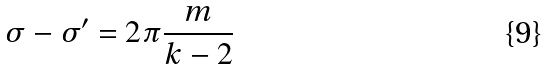Convert formula to latex. <formula><loc_0><loc_0><loc_500><loc_500>\sigma - \sigma ^ { \prime } = 2 \pi \frac { m } { k - 2 }</formula> 